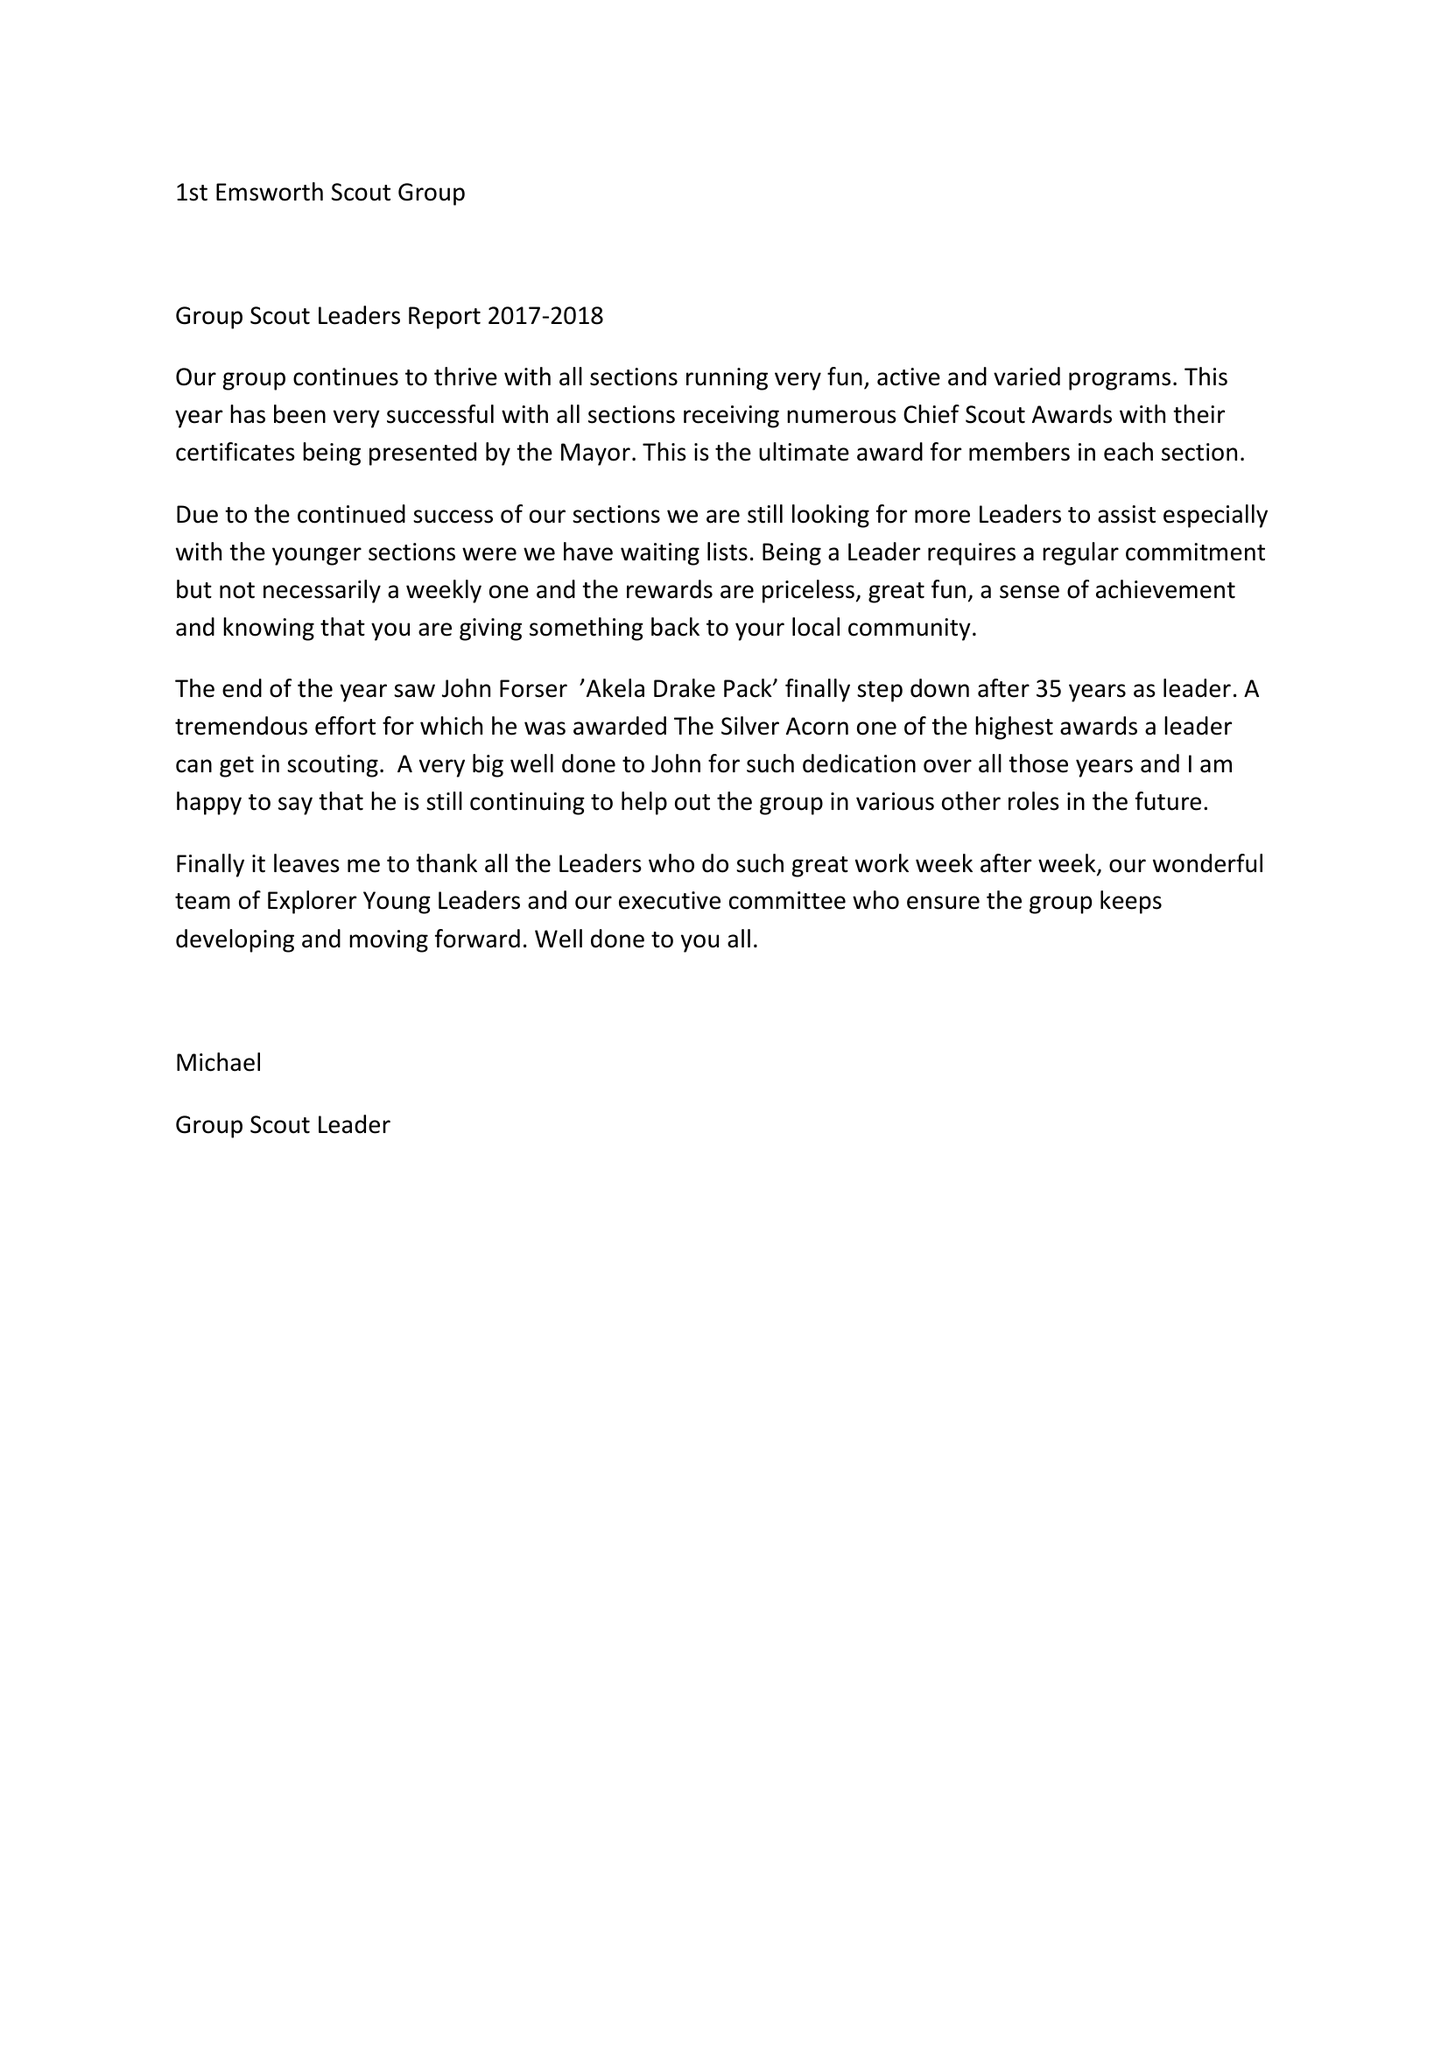What is the value for the spending_annually_in_british_pounds?
Answer the question using a single word or phrase. 23837.00 